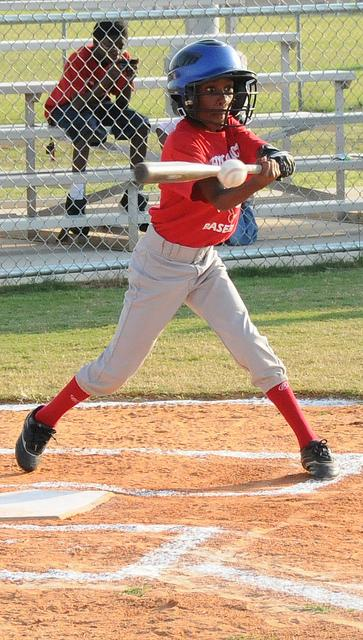What team wears similar socks to the boy in the foreground? Please explain your reasoning. red sox. The team is the red sox. 